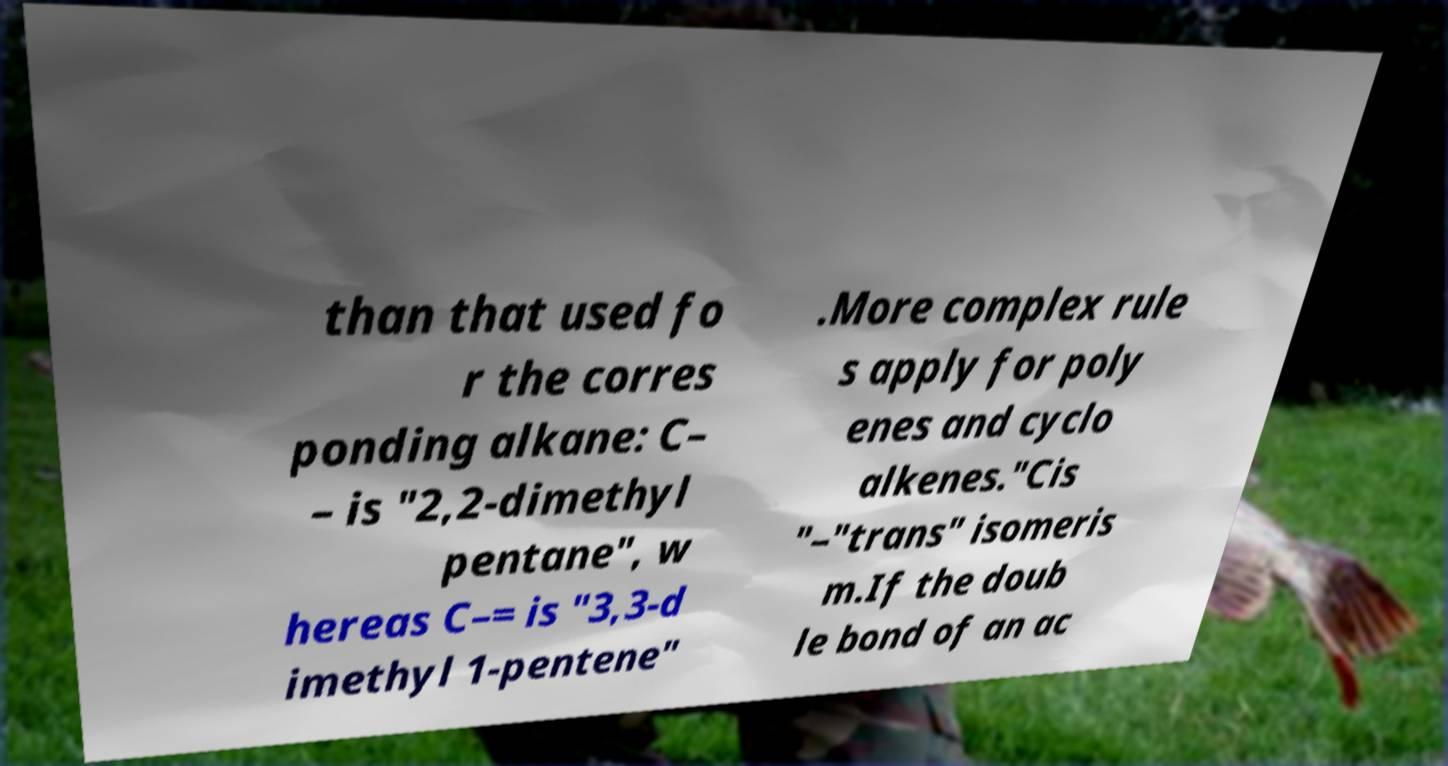Can you accurately transcribe the text from the provided image for me? than that used fo r the corres ponding alkane: C– – is "2,2-dimethyl pentane", w hereas C–= is "3,3-d imethyl 1-pentene" .More complex rule s apply for poly enes and cyclo alkenes."Cis "–"trans" isomeris m.If the doub le bond of an ac 